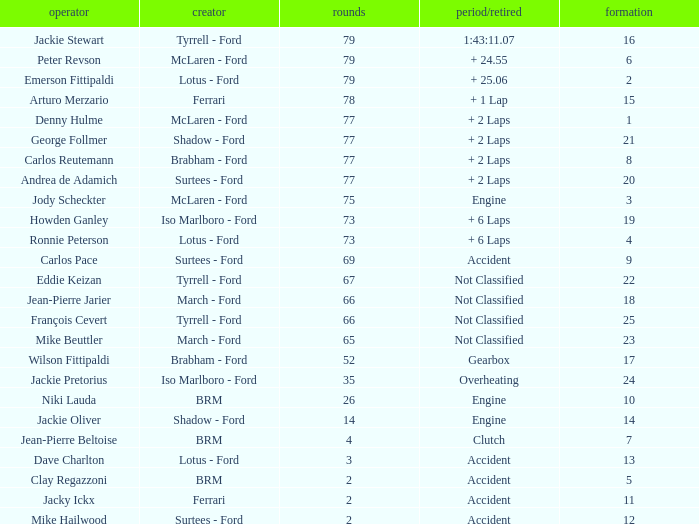How much time is required for less than 35 laps and less than 10 grids? Clutch, Accident. 